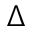Convert formula to latex. <formula><loc_0><loc_0><loc_500><loc_500>\Delta</formula> 